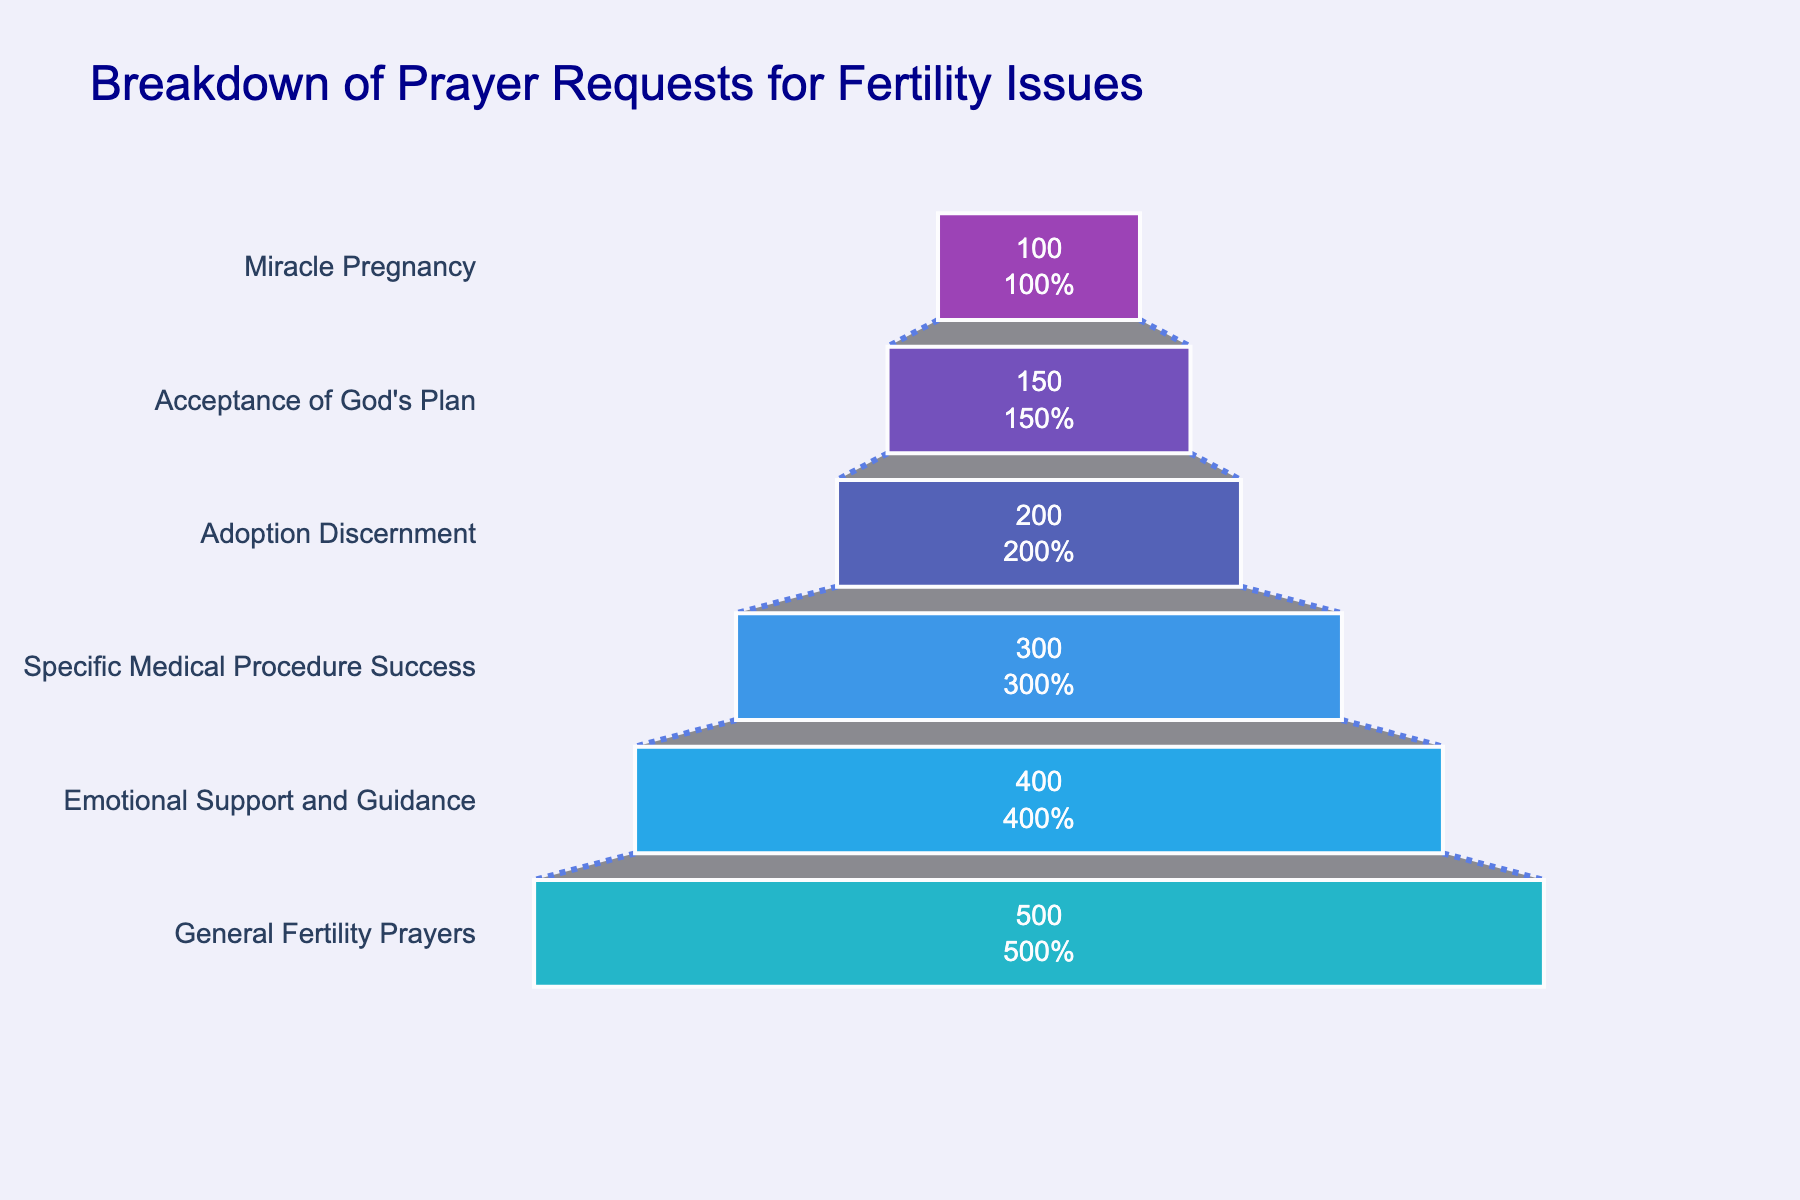How many stages are represented in the funnel chart? The stages can be counted individually in the funnel from top to bottom. These stages include "General Fertility Prayers," "Emotional Support and Guidance," "Specific Medical Procedure Success," "Adoption Discernment," "Acceptance of God's Plan," and "Miracle Pregnancy."
Answer: 6 What is the highest number of prayer requests received for a specific stage? By observing the lengths of the bars, we can see that the longest bar corresponds to "General Fertility Prayers," which has the highest number of requests.
Answer: 500 Which stage has the least number of prayer requests? The shortest bar in the funnel chart represents the stage with the least number of prayer requests, which is "Miracle Pregnancy."
Answer: Miracle Pregnancy How many more requests were received for "General Fertility Prayers" compared to "Adoption Discernment"? Subtract the number of requests for "Adoption Discernment" from those for "General Fertility Prayers" (i.e., 500 - 200).
Answer: 300 What percentage of the total prayer requests does "Emotional Support and Guidance" represent? First, sum the total number of requests across all stages [(500 + 400 + 300 + 200 + 150 + 100) = 1650]. Then divide the number of requests for "Emotional Support and Guidance" by this total and multiply by 100 to convert it to a percentage (i.e., (400 / 1650) * 100).
Answer: 24.24% Are there more requests for "Acceptance of God's Plan" or "Specific Medical Procedure Success"? By comparing the lengths of the bars, we see that "Specific Medical Procedure Success" received more requests than "Acceptance of God's Plan."
Answer: Specific Medical Procedure Success What is the combined number of requests for "Adoption Discernment" and "Acceptance of God's Plan"? Sum the number of requests for both stages (i.e., 200 + 150).
Answer: 350 What is the ratio of prayer requests for "Miracle Pregnancy" to those for "Specific Medical Procedure Success"? Divide the number of requests for "Miracle Pregnancy" by those for "Specific Medical Procedure Success" (i.e., 100 / 300).
Answer: 1:3 Which color is used to represent "Emotional Support and Guidance" in the chart? By observing the color assignment, "Emotional Support and Guidance" is shown in a darker purple color.
Answer: Dark purple (Hex: #5E35B1) 